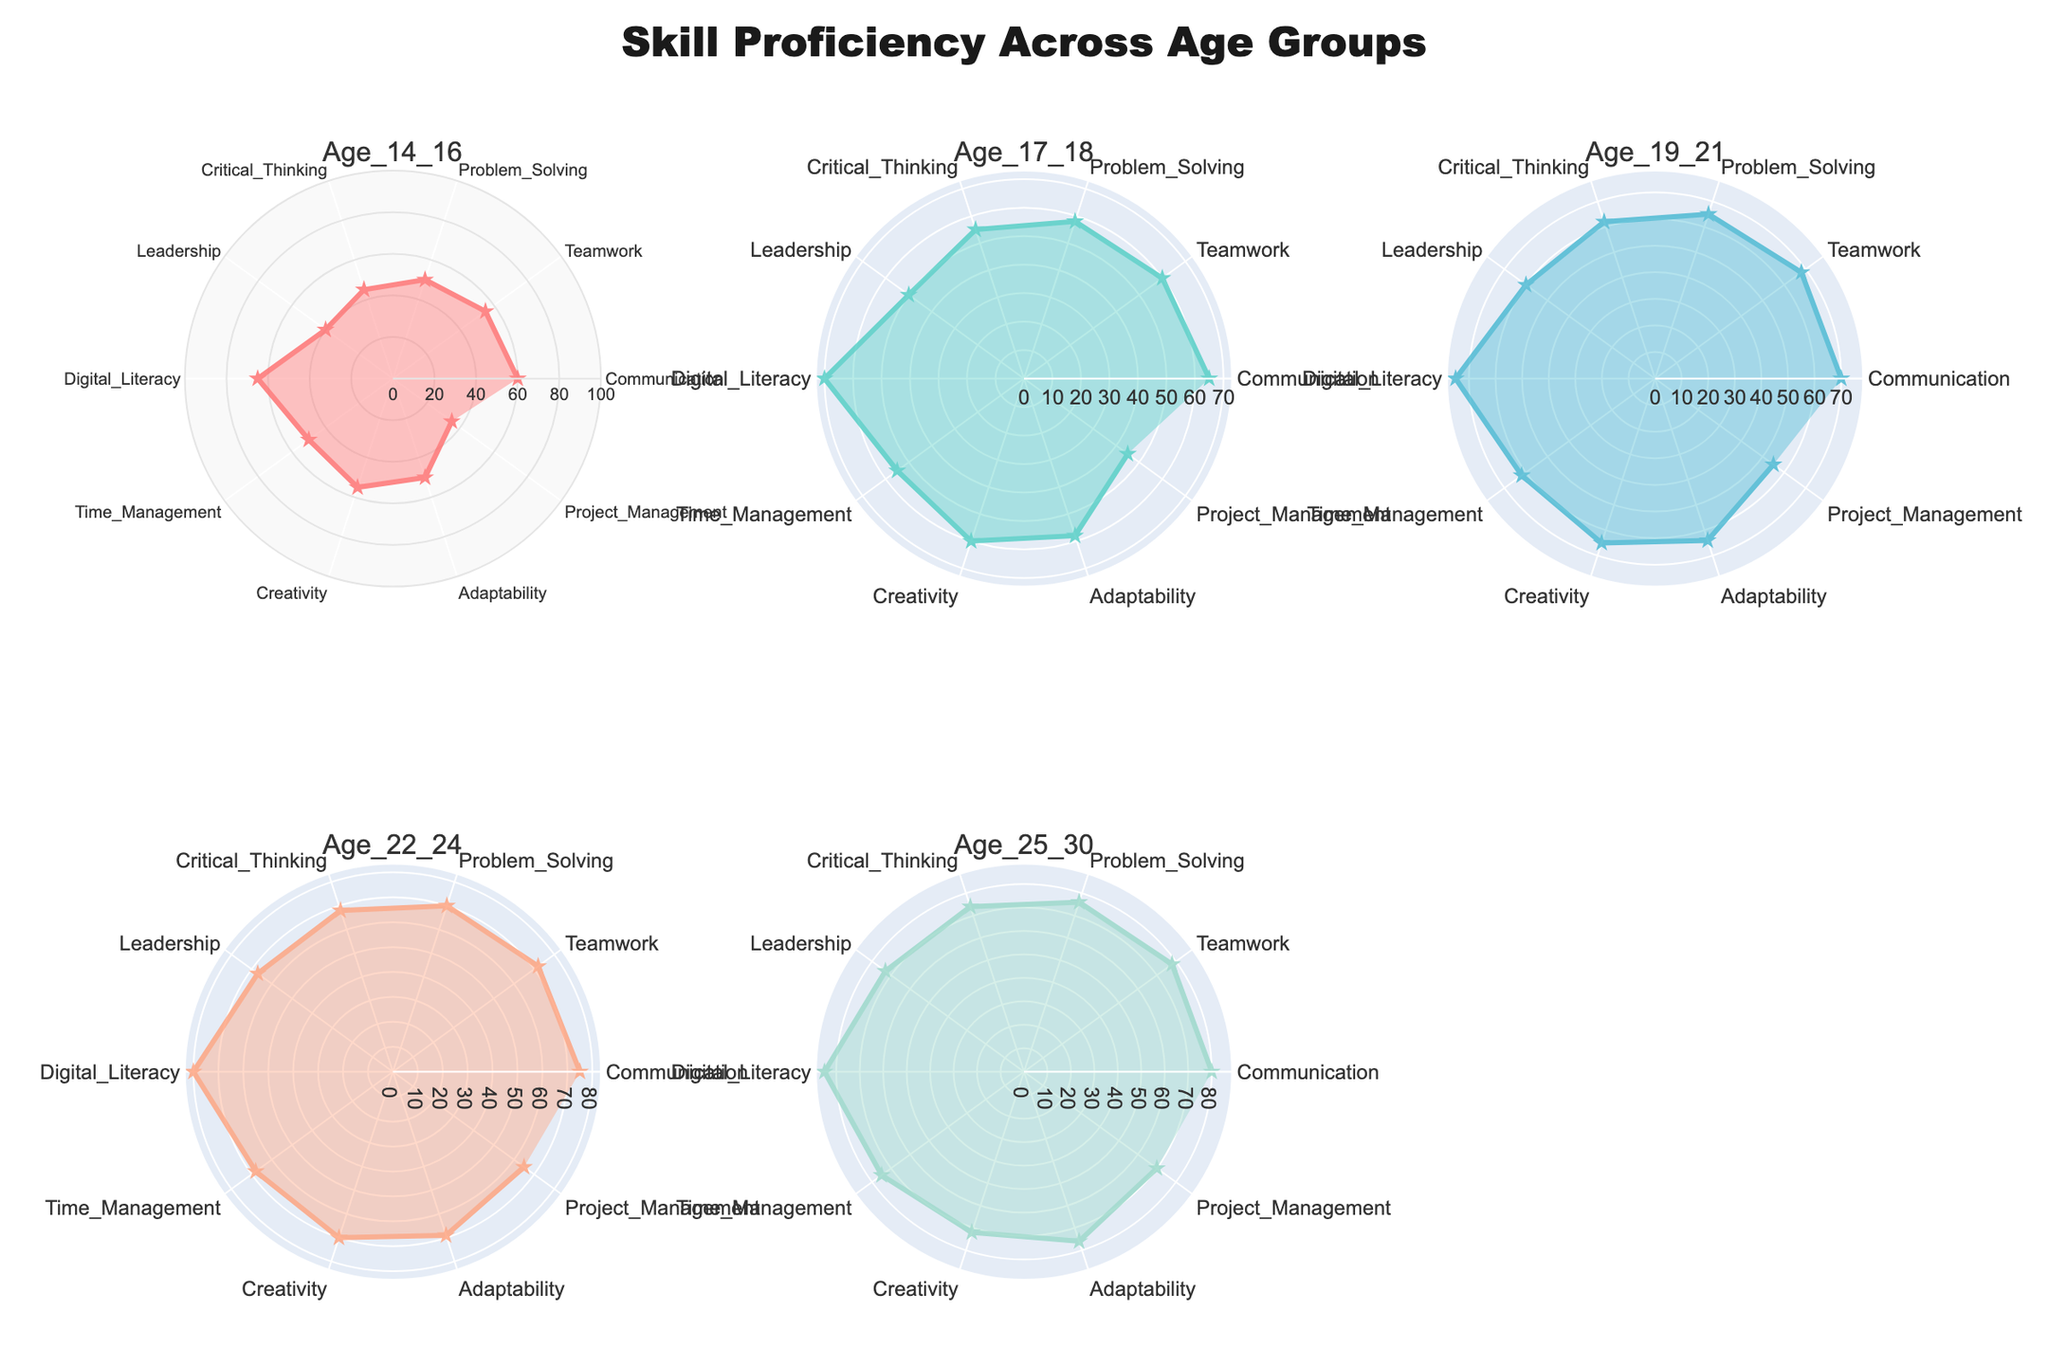What is the title of the figure? The title is typically located at the top of the figure, in a larger font than the rest of the text. The title provides a summary of what the visual is about. Here, the title is clearly identified as "Skill Proficiency Across Age Groups".
Answer: Skill Proficiency Across Age Groups Which age group shows the highest proficiency in Digital Literacy? Examining the plots for each age group, we look at the value corresponding to Digital Literacy. The highest value among the age groups for Digital Literacy is in Age 25-30, which shows a proficiency level of 85.
Answer: Age 25-30 How does the proficiency in Leadership change as age increases? To answer this, we observe the values for Leadership across the age groups: Age 14-16 (40), Age 17-18 (50), Age 19-21 (60), Age 22-24 (67), Age 25-30 (73). Noting each value, we see a general increase in leadership proficiency as age increases.
Answer: Increases What is the average proficiency level in Problem Solving across all age groups? To find the average, sum the proficiency levels for Problem Solving for all age groups: 50 (Age 14-16) + 58 (Age 17-18) + 65 (Age 19-21) + 70 (Age 22-24) + 76 (Age 25-30). This total is 319. Dividing by the number of age groups (5), the average proficiency level is 319/5 = 63.8.
Answer: 63.8 Which skill shows the least improvement from Age 14-16 to Age 25-30? To identify the skill with the least improvement, calculate the difference between the proficiency levels at Age 14-16 and Age 25-30 for each skill. The differences are: Communication (20), Teamwork (23), Problem Solving (26), Critical Thinking (29), Leadership (33), Digital Literacy (20), Time Management (25), Creativity (17), Adaptability (26), Project Management (35). The skill with the smallest difference is Creativity (17).
Answer: Creativity Between which two consecutive age groups is the increase in Time Management proficiency the greatest? We need to determine the differences in Time Management proficiency between consecutive age groups: Age 14-16 to 17-18 (55-50=5), Age 17-18 to 19-21 (62-55=7), Age 19-21 to 22-24 (68-62=6), Age 22-24 to 25-30 (75-68=7). The greatest increase is tied between Age 17-18 to 19-21 and Age 22-24 to 25-30, both with an increase of 7.
Answer: Age 17-18 to 19-21 and Age 22-24 to 25-30 Compare the proficiency in Communication between Age 17-18 and Age 22-24. Which age group has higher proficiency? Looking at the data points for Communication: Age 17-18 (65) and Age 22-24 (75), we can see that the proficiency in Communication is higher for Age 22-24 compared to Age 17-18.
Answer: Age 22-24 What is the range of proficiency levels for Project Management across all age groups? The proficiency levels for Project Management are: Age 14-16 (35), Age 17-18 (45), Age 19-21 (55), Age 22-24 (65), Age 25-30 (70). The range is calculated as the difference between the maximum and minimum values: 70 - 35 = 35.
Answer: 35 